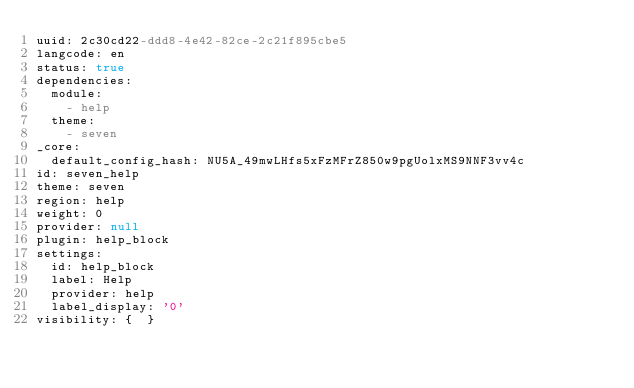<code> <loc_0><loc_0><loc_500><loc_500><_YAML_>uuid: 2c30cd22-ddd8-4e42-82ce-2c21f895cbe5
langcode: en
status: true
dependencies:
  module:
    - help
  theme:
    - seven
_core:
  default_config_hash: NU5A_49mwLHfs5xFzMFrZ850w9pgUolxMS9NNF3vv4c
id: seven_help
theme: seven
region: help
weight: 0
provider: null
plugin: help_block
settings:
  id: help_block
  label: Help
  provider: help
  label_display: '0'
visibility: {  }
</code> 